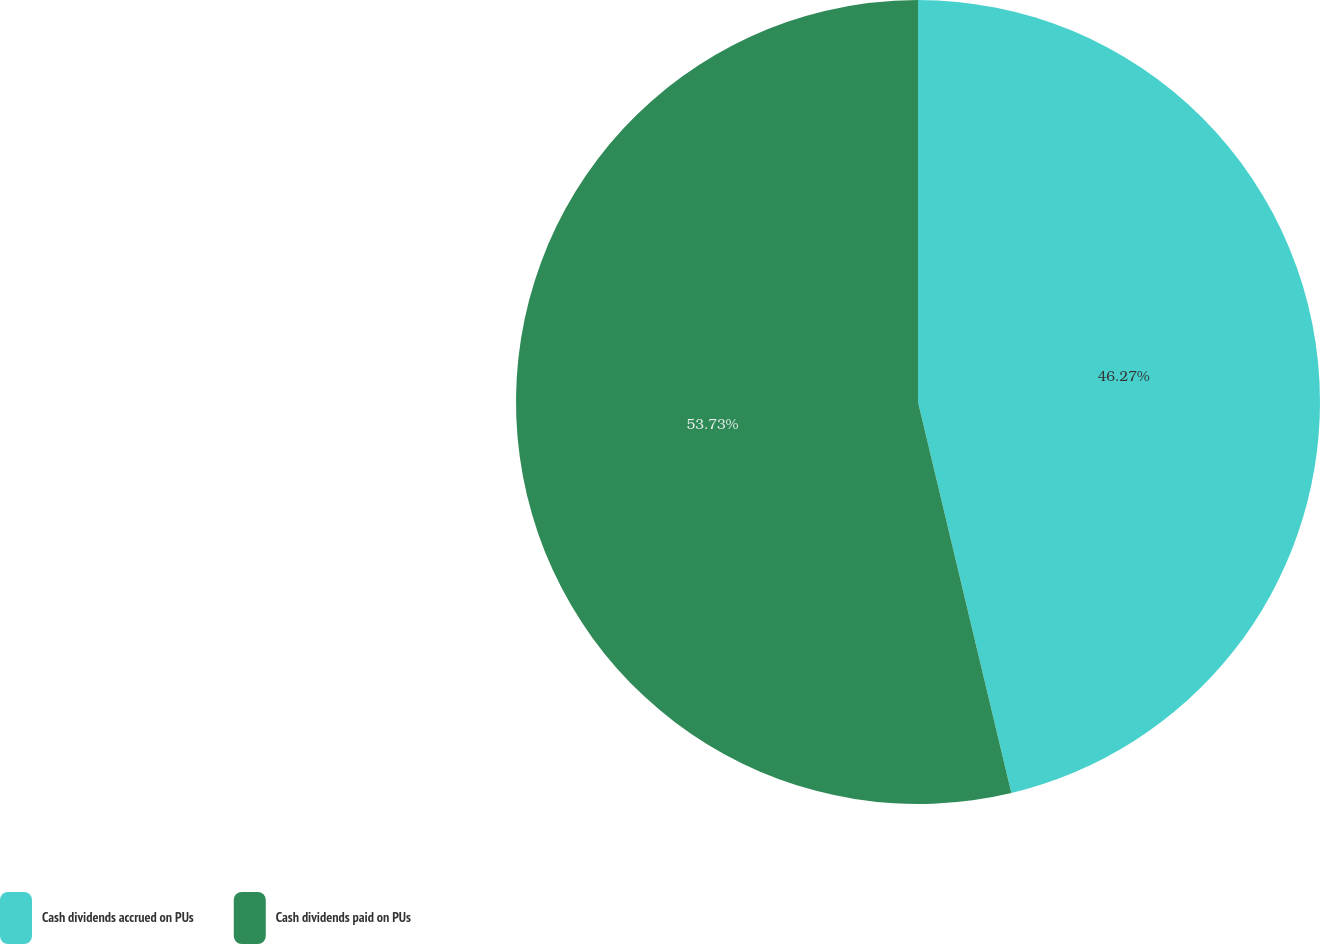Convert chart to OTSL. <chart><loc_0><loc_0><loc_500><loc_500><pie_chart><fcel>Cash dividends accrued on PUs<fcel>Cash dividends paid on PUs<nl><fcel>46.27%<fcel>53.73%<nl></chart> 